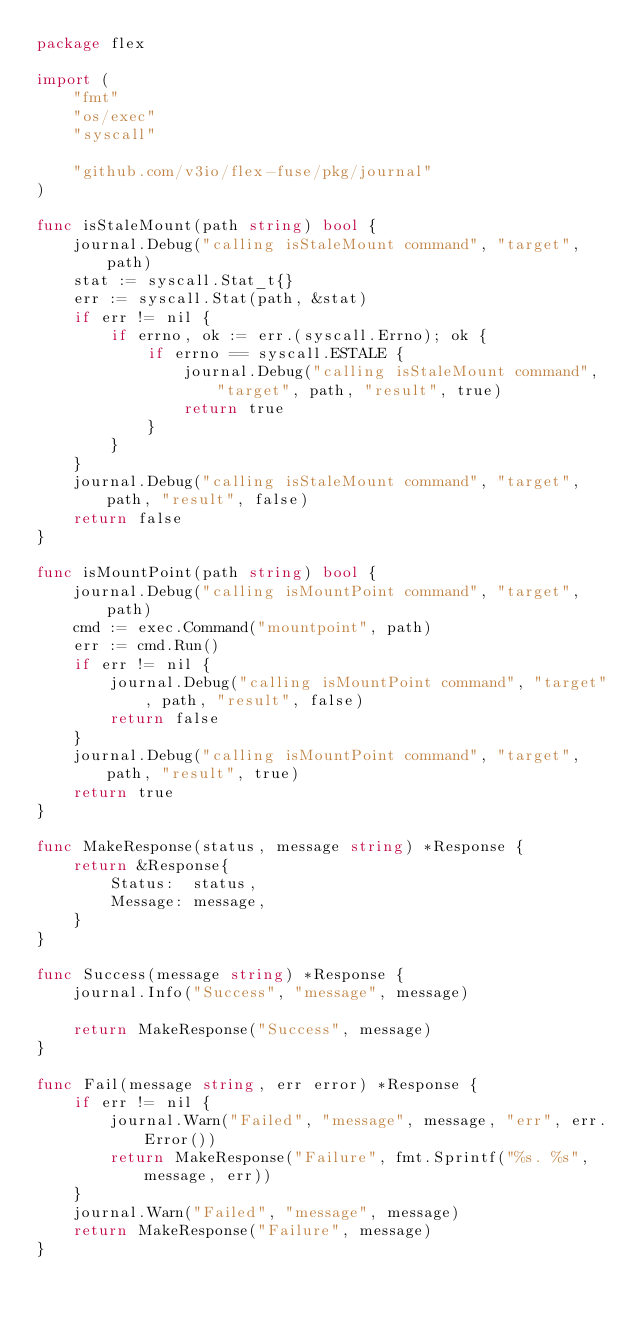Convert code to text. <code><loc_0><loc_0><loc_500><loc_500><_Go_>package flex

import (
	"fmt"
	"os/exec"
	"syscall"

	"github.com/v3io/flex-fuse/pkg/journal"
)

func isStaleMount(path string) bool {
	journal.Debug("calling isStaleMount command", "target", path)
	stat := syscall.Stat_t{}
	err := syscall.Stat(path, &stat)
	if err != nil {
		if errno, ok := err.(syscall.Errno); ok {
			if errno == syscall.ESTALE {
				journal.Debug("calling isStaleMount command", "target", path, "result", true)
				return true
			}
		}
	}
	journal.Debug("calling isStaleMount command", "target", path, "result", false)
	return false
}

func isMountPoint(path string) bool {
	journal.Debug("calling isMountPoint command", "target", path)
	cmd := exec.Command("mountpoint", path)
	err := cmd.Run()
	if err != nil {
		journal.Debug("calling isMountPoint command", "target", path, "result", false)
		return false
	}
	journal.Debug("calling isMountPoint command", "target", path, "result", true)
	return true
}

func MakeResponse(status, message string) *Response {
	return &Response{
		Status:  status,
		Message: message,
	}
}

func Success(message string) *Response {
	journal.Info("Success", "message", message)

	return MakeResponse("Success", message)
}

func Fail(message string, err error) *Response {
	if err != nil {
		journal.Warn("Failed", "message", message, "err", err.Error())
		return MakeResponse("Failure", fmt.Sprintf("%s. %s", message, err))
	}
	journal.Warn("Failed", "message", message)
	return MakeResponse("Failure", message)
}
</code> 